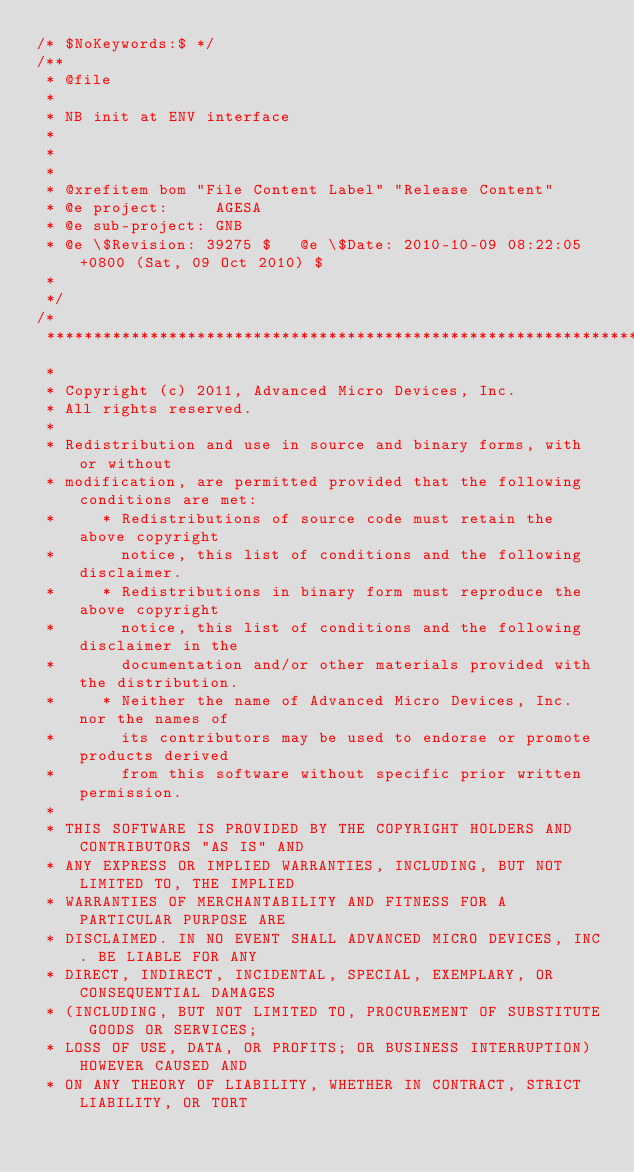<code> <loc_0><loc_0><loc_500><loc_500><_C_>/* $NoKeywords:$ */
/**
 * @file
 *
 * NB init at ENV interface
 *
 *
 *
 * @xrefitem bom "File Content Label" "Release Content"
 * @e project:     AGESA
 * @e sub-project: GNB
 * @e \$Revision: 39275 $   @e \$Date: 2010-10-09 08:22:05 +0800 (Sat, 09 Oct 2010) $
 *
 */
/*
 *****************************************************************************
 *
 * Copyright (c) 2011, Advanced Micro Devices, Inc.
 * All rights reserved.
 * 
 * Redistribution and use in source and binary forms, with or without
 * modification, are permitted provided that the following conditions are met:
 *     * Redistributions of source code must retain the above copyright
 *       notice, this list of conditions and the following disclaimer.
 *     * Redistributions in binary form must reproduce the above copyright
 *       notice, this list of conditions and the following disclaimer in the
 *       documentation and/or other materials provided with the distribution.
 *     * Neither the name of Advanced Micro Devices, Inc. nor the names of 
 *       its contributors may be used to endorse or promote products derived 
 *       from this software without specific prior written permission.
 * 
 * THIS SOFTWARE IS PROVIDED BY THE COPYRIGHT HOLDERS AND CONTRIBUTORS "AS IS" AND
 * ANY EXPRESS OR IMPLIED WARRANTIES, INCLUDING, BUT NOT LIMITED TO, THE IMPLIED
 * WARRANTIES OF MERCHANTABILITY AND FITNESS FOR A PARTICULAR PURPOSE ARE
 * DISCLAIMED. IN NO EVENT SHALL ADVANCED MICRO DEVICES, INC. BE LIABLE FOR ANY
 * DIRECT, INDIRECT, INCIDENTAL, SPECIAL, EXEMPLARY, OR CONSEQUENTIAL DAMAGES
 * (INCLUDING, BUT NOT LIMITED TO, PROCUREMENT OF SUBSTITUTE GOODS OR SERVICES;
 * LOSS OF USE, DATA, OR PROFITS; OR BUSINESS INTERRUPTION) HOWEVER CAUSED AND
 * ON ANY THEORY OF LIABILITY, WHETHER IN CONTRACT, STRICT LIABILITY, OR TORT</code> 